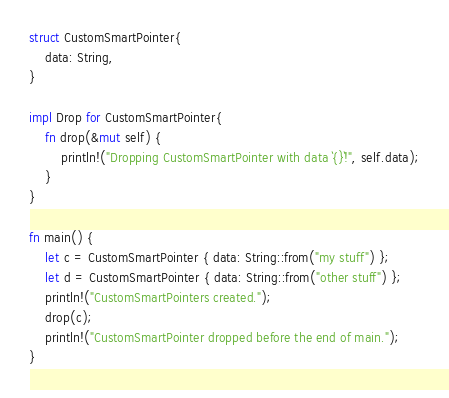Convert code to text. <code><loc_0><loc_0><loc_500><loc_500><_Rust_>struct CustomSmartPointer{
    data: String,
}

impl Drop for CustomSmartPointer{
    fn drop(&mut self) {
        println!("Dropping CustomSmartPointer with data `{}`!", self.data);
    }
}

fn main() {
    let c = CustomSmartPointer { data: String::from("my stuff") };
    let d = CustomSmartPointer { data: String::from("other stuff") };
    println!("CustomSmartPointers created.");
    drop(c);
    println!("CustomSmartPointer dropped before the end of main.");
}
</code> 